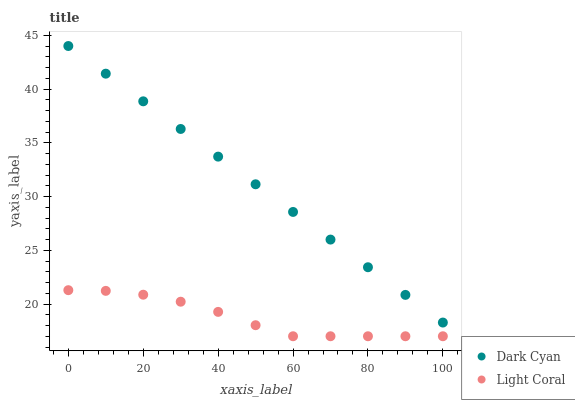Does Light Coral have the minimum area under the curve?
Answer yes or no. Yes. Does Dark Cyan have the maximum area under the curve?
Answer yes or no. Yes. Does Light Coral have the maximum area under the curve?
Answer yes or no. No. Is Dark Cyan the smoothest?
Answer yes or no. Yes. Is Light Coral the roughest?
Answer yes or no. Yes. Is Light Coral the smoothest?
Answer yes or no. No. Does Light Coral have the lowest value?
Answer yes or no. Yes. Does Dark Cyan have the highest value?
Answer yes or no. Yes. Does Light Coral have the highest value?
Answer yes or no. No. Is Light Coral less than Dark Cyan?
Answer yes or no. Yes. Is Dark Cyan greater than Light Coral?
Answer yes or no. Yes. Does Light Coral intersect Dark Cyan?
Answer yes or no. No. 